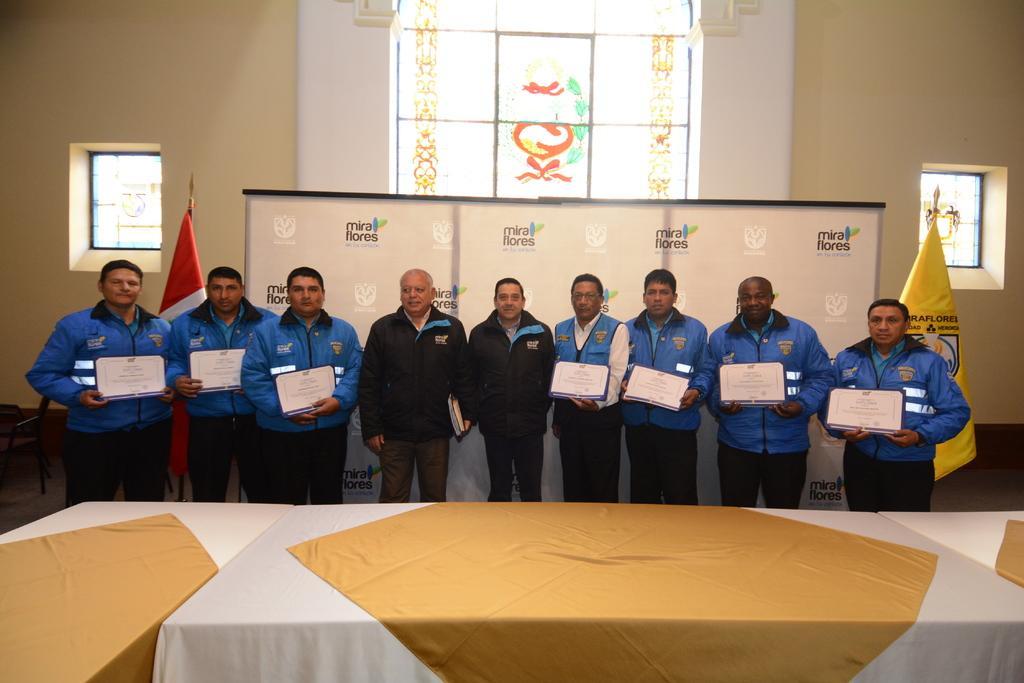Please provide a concise description of this image. In this image, we can see a group of people are standing. Few people are holding some objects. At the bottom of the image, we can see tables covered with clothes. In the background, we can see banner, flags, wall, chair and glass objects. 